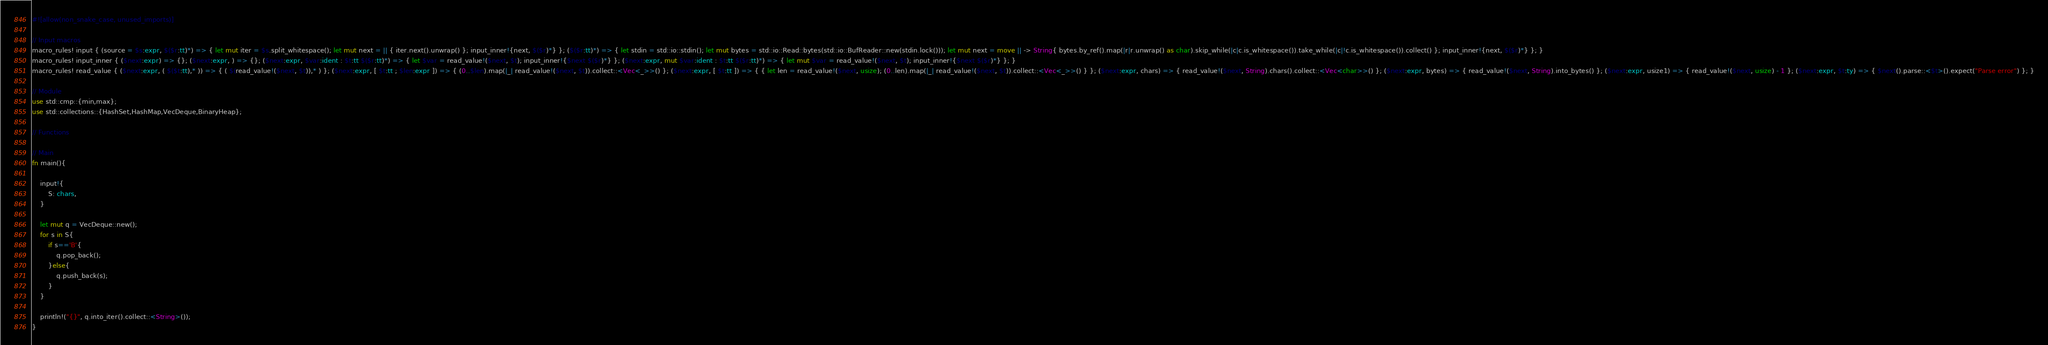Convert code to text. <code><loc_0><loc_0><loc_500><loc_500><_Rust_>#![allow(non_snake_case, unused_imports)]

// Input macros
macro_rules! input { (source = $s:expr, $($r:tt)*) => { let mut iter = $s.split_whitespace(); let mut next = || { iter.next().unwrap() }; input_inner!{next, $($r)*} }; ($($r:tt)*) => { let stdin = std::io::stdin(); let mut bytes = std::io::Read::bytes(std::io::BufReader::new(stdin.lock())); let mut next = move || -> String{ bytes.by_ref().map(|r|r.unwrap() as char).skip_while(|c|c.is_whitespace()).take_while(|c|!c.is_whitespace()).collect() }; input_inner!{next, $($r)*} }; }
macro_rules! input_inner { ($next:expr) => {}; ($next:expr, ) => {}; ($next:expr, $var:ident : $t:tt $($r:tt)*) => { let $var = read_value!($next, $t); input_inner!{$next $($r)*} }; ($next:expr, mut $var:ident : $t:tt $($r:tt)*) => { let mut $var = read_value!($next, $t); input_inner!{$next $($r)*} }; }
macro_rules! read_value { ($next:expr, ( $($t:tt),* )) => { ( $(read_value!($next, $t)),* ) }; ($next:expr, [ $t:tt ; $len:expr ]) => { (0..$len).map(|_| read_value!($next, $t)).collect::<Vec<_>>() }; ($next:expr, [ $t:tt ]) => { { let len = read_value!($next, usize); (0..len).map(|_| read_value!($next, $t)).collect::<Vec<_>>() } }; ($next:expr, chars) => { read_value!($next, String).chars().collect::<Vec<char>>() }; ($next:expr, bytes) => { read_value!($next, String).into_bytes() }; ($next:expr, usize1) => { read_value!($next, usize) - 1 }; ($next:expr, $t:ty) => { $next().parse::<$t>().expect("Parse error") }; }

// Module
use std::cmp::{min,max};
use std::collections::{HashSet,HashMap,VecDeque,BinaryHeap};

// Functions

// Main
fn main(){

    input!{
        S: chars,
    }

    let mut q = VecDeque::new();
    for s in S{
        if s=='B'{
            q.pop_back();
        }else{
            q.push_back(s);
        }
    }

    println!("{}", q.into_iter().collect::<String>());
}</code> 